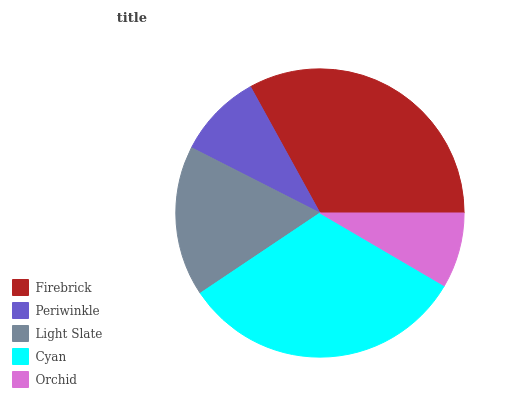Is Orchid the minimum?
Answer yes or no. Yes. Is Firebrick the maximum?
Answer yes or no. Yes. Is Periwinkle the minimum?
Answer yes or no. No. Is Periwinkle the maximum?
Answer yes or no. No. Is Firebrick greater than Periwinkle?
Answer yes or no. Yes. Is Periwinkle less than Firebrick?
Answer yes or no. Yes. Is Periwinkle greater than Firebrick?
Answer yes or no. No. Is Firebrick less than Periwinkle?
Answer yes or no. No. Is Light Slate the high median?
Answer yes or no. Yes. Is Light Slate the low median?
Answer yes or no. Yes. Is Periwinkle the high median?
Answer yes or no. No. Is Cyan the low median?
Answer yes or no. No. 